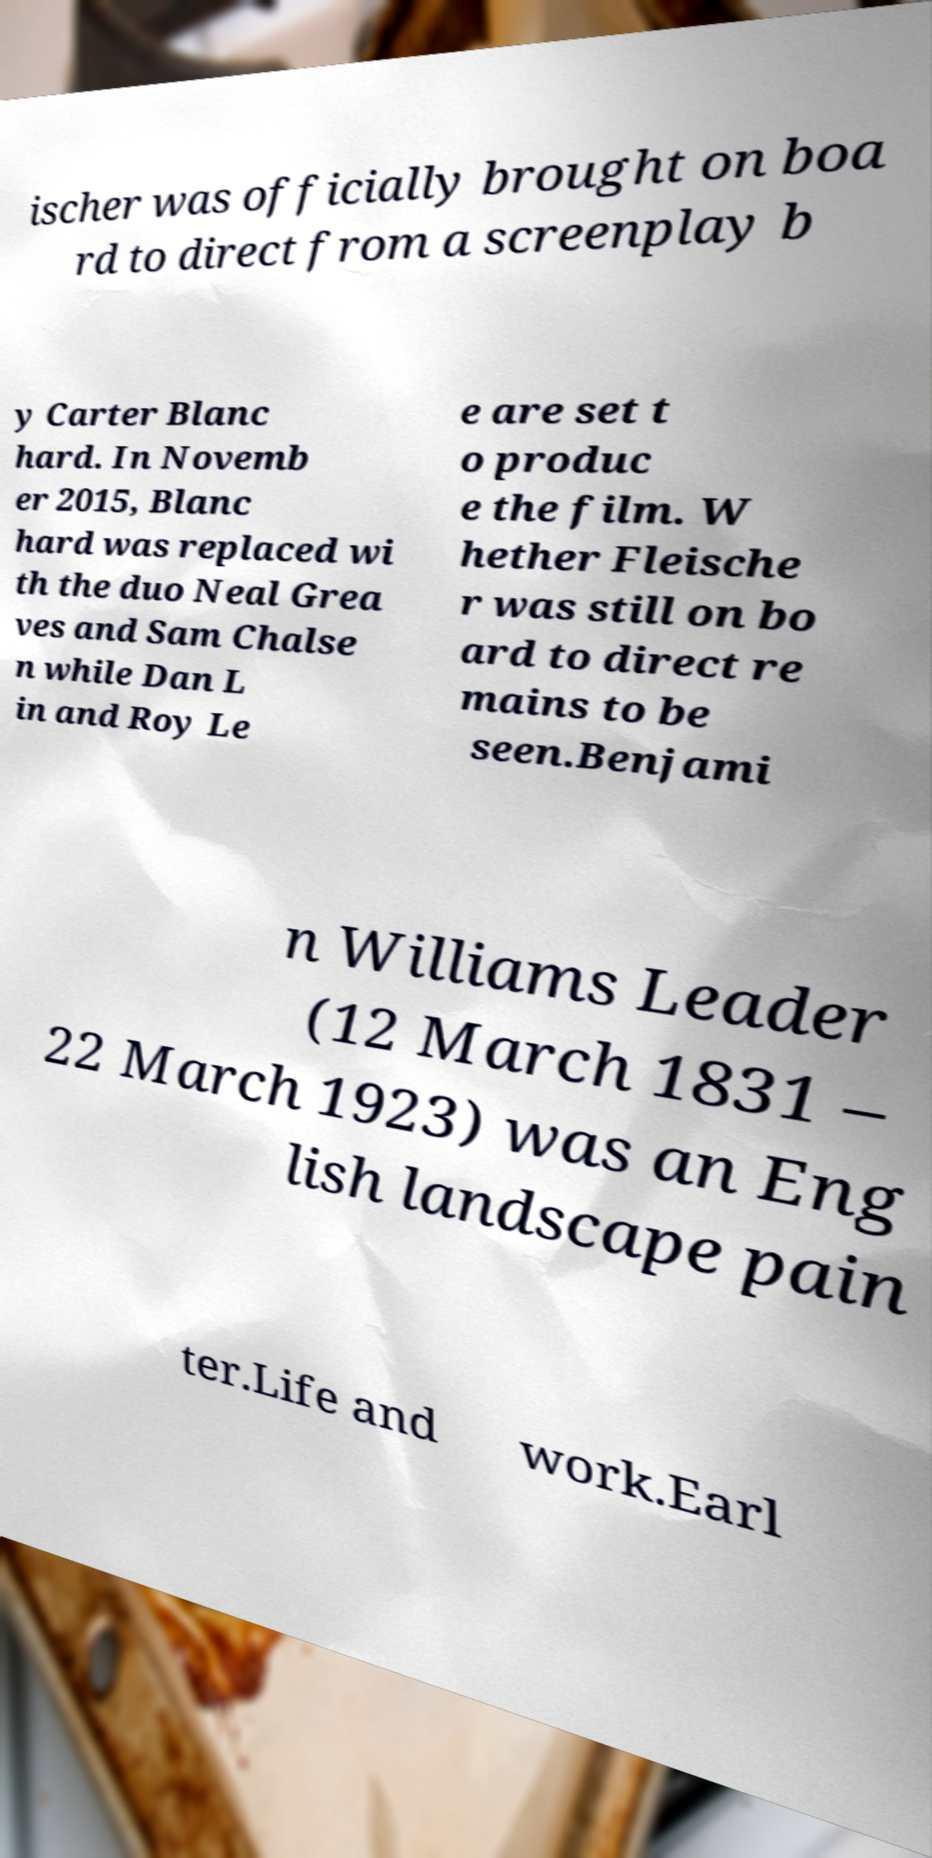Can you read and provide the text displayed in the image?This photo seems to have some interesting text. Can you extract and type it out for me? ischer was officially brought on boa rd to direct from a screenplay b y Carter Blanc hard. In Novemb er 2015, Blanc hard was replaced wi th the duo Neal Grea ves and Sam Chalse n while Dan L in and Roy Le e are set t o produc e the film. W hether Fleische r was still on bo ard to direct re mains to be seen.Benjami n Williams Leader (12 March 1831 – 22 March 1923) was an Eng lish landscape pain ter.Life and work.Earl 